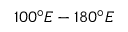Convert formula to latex. <formula><loc_0><loc_0><loc_500><loc_500>1 0 0 ^ { \circ } E - 1 8 0 ^ { \circ } E</formula> 